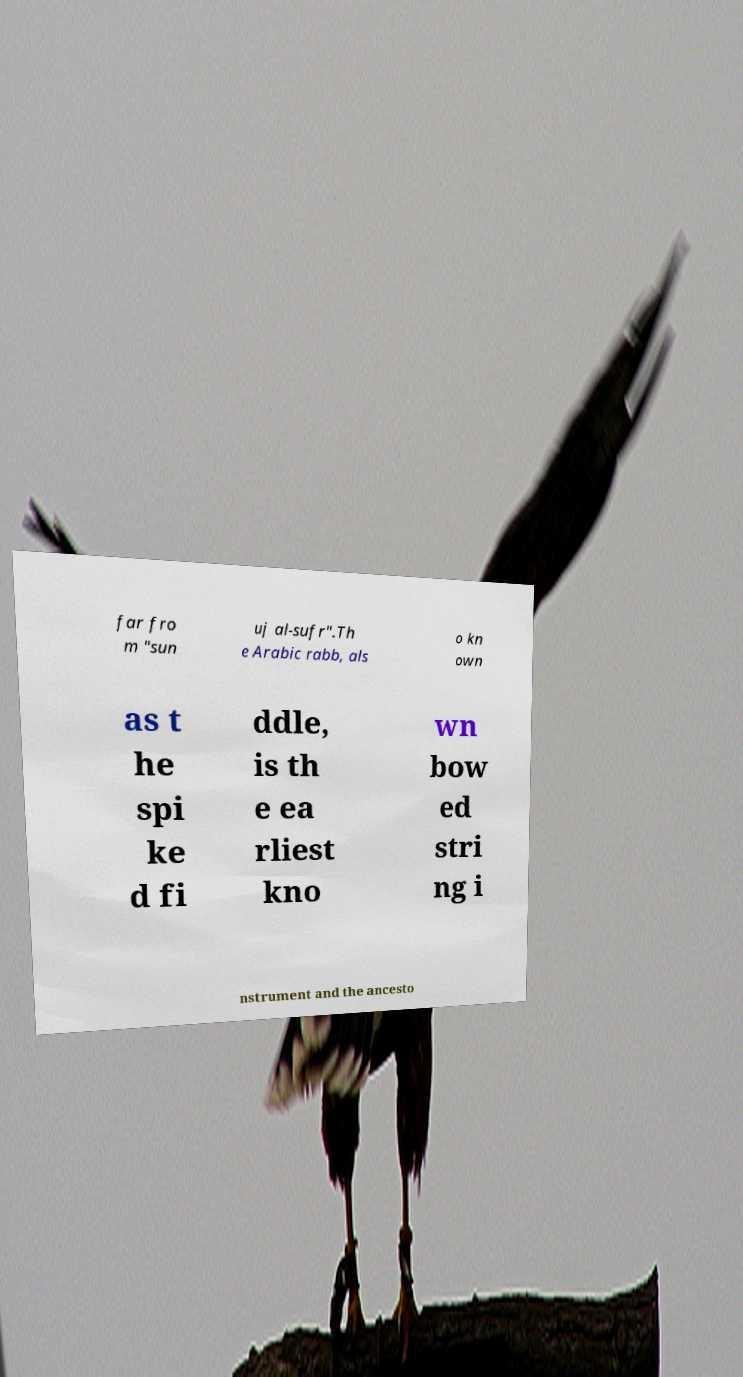What messages or text are displayed in this image? I need them in a readable, typed format. far fro m "sun uj al-sufr".Th e Arabic rabb, als o kn own as t he spi ke d fi ddle, is th e ea rliest kno wn bow ed stri ng i nstrument and the ancesto 